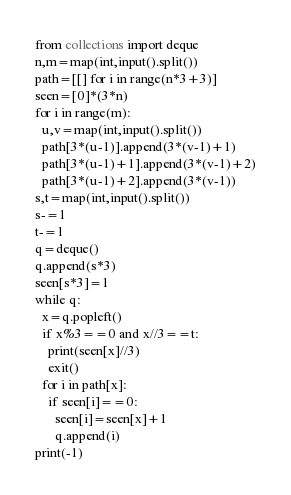Convert code to text. <code><loc_0><loc_0><loc_500><loc_500><_Python_>from collections import deque
n,m=map(int,input().split())
path=[[] for i in range(n*3+3)]
seen=[0]*(3*n)
for i in range(m):
  u,v=map(int,input().split())
  path[3*(u-1)].append(3*(v-1)+1)
  path[3*(u-1)+1].append(3*(v-1)+2)
  path[3*(u-1)+2].append(3*(v-1))
s,t=map(int,input().split())
s-=1
t-=1
q=deque()
q.append(s*3)
seen[s*3]=1
while q:
  x=q.popleft()
  if x%3==0 and x//3==t:
    print(seen[x]//3)
    exit()
  for i in path[x]:
    if seen[i]==0:
      seen[i]=seen[x]+1
      q.append(i)
print(-1)</code> 